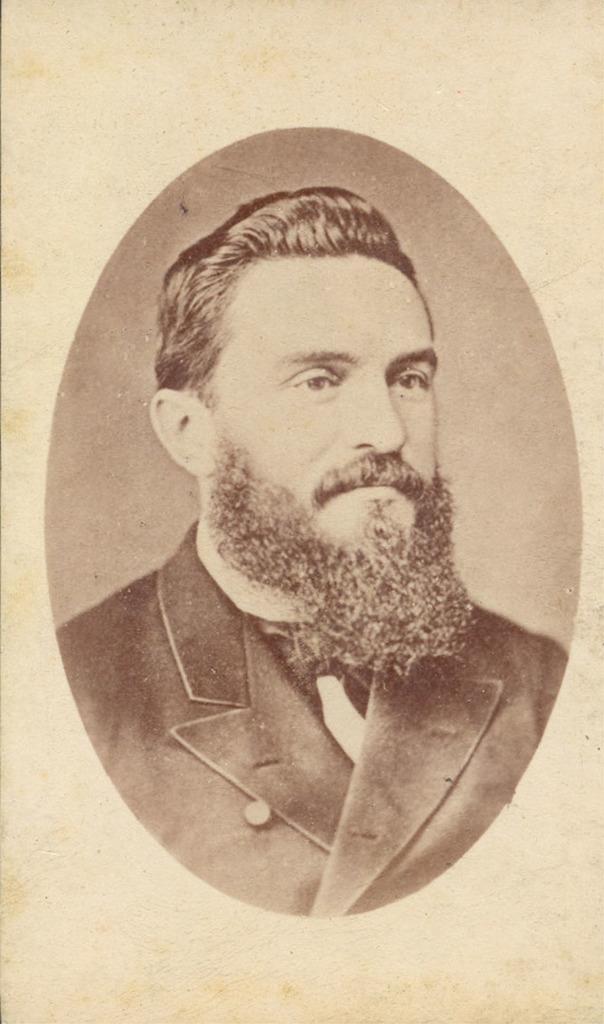In one or two sentences, can you explain what this image depicts? In this image there is a photo of a person. 